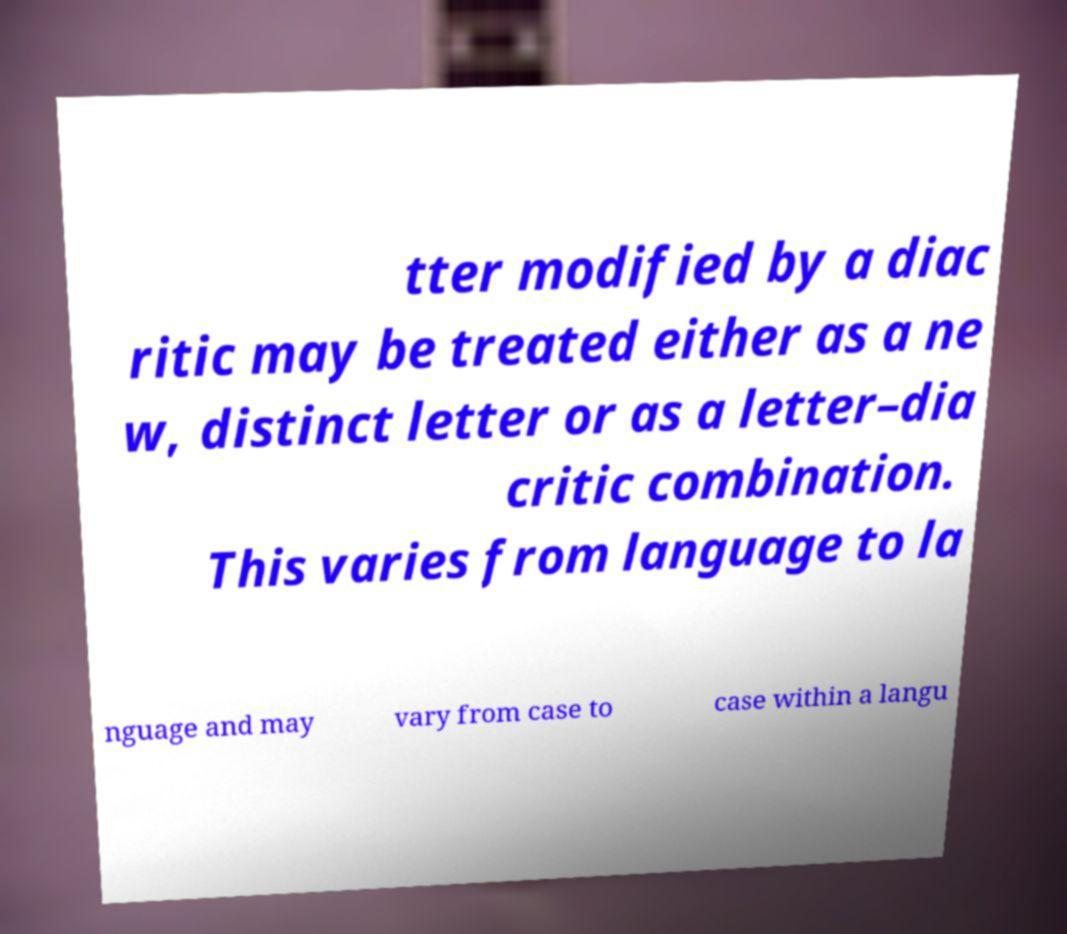I need the written content from this picture converted into text. Can you do that? tter modified by a diac ritic may be treated either as a ne w, distinct letter or as a letter–dia critic combination. This varies from language to la nguage and may vary from case to case within a langu 